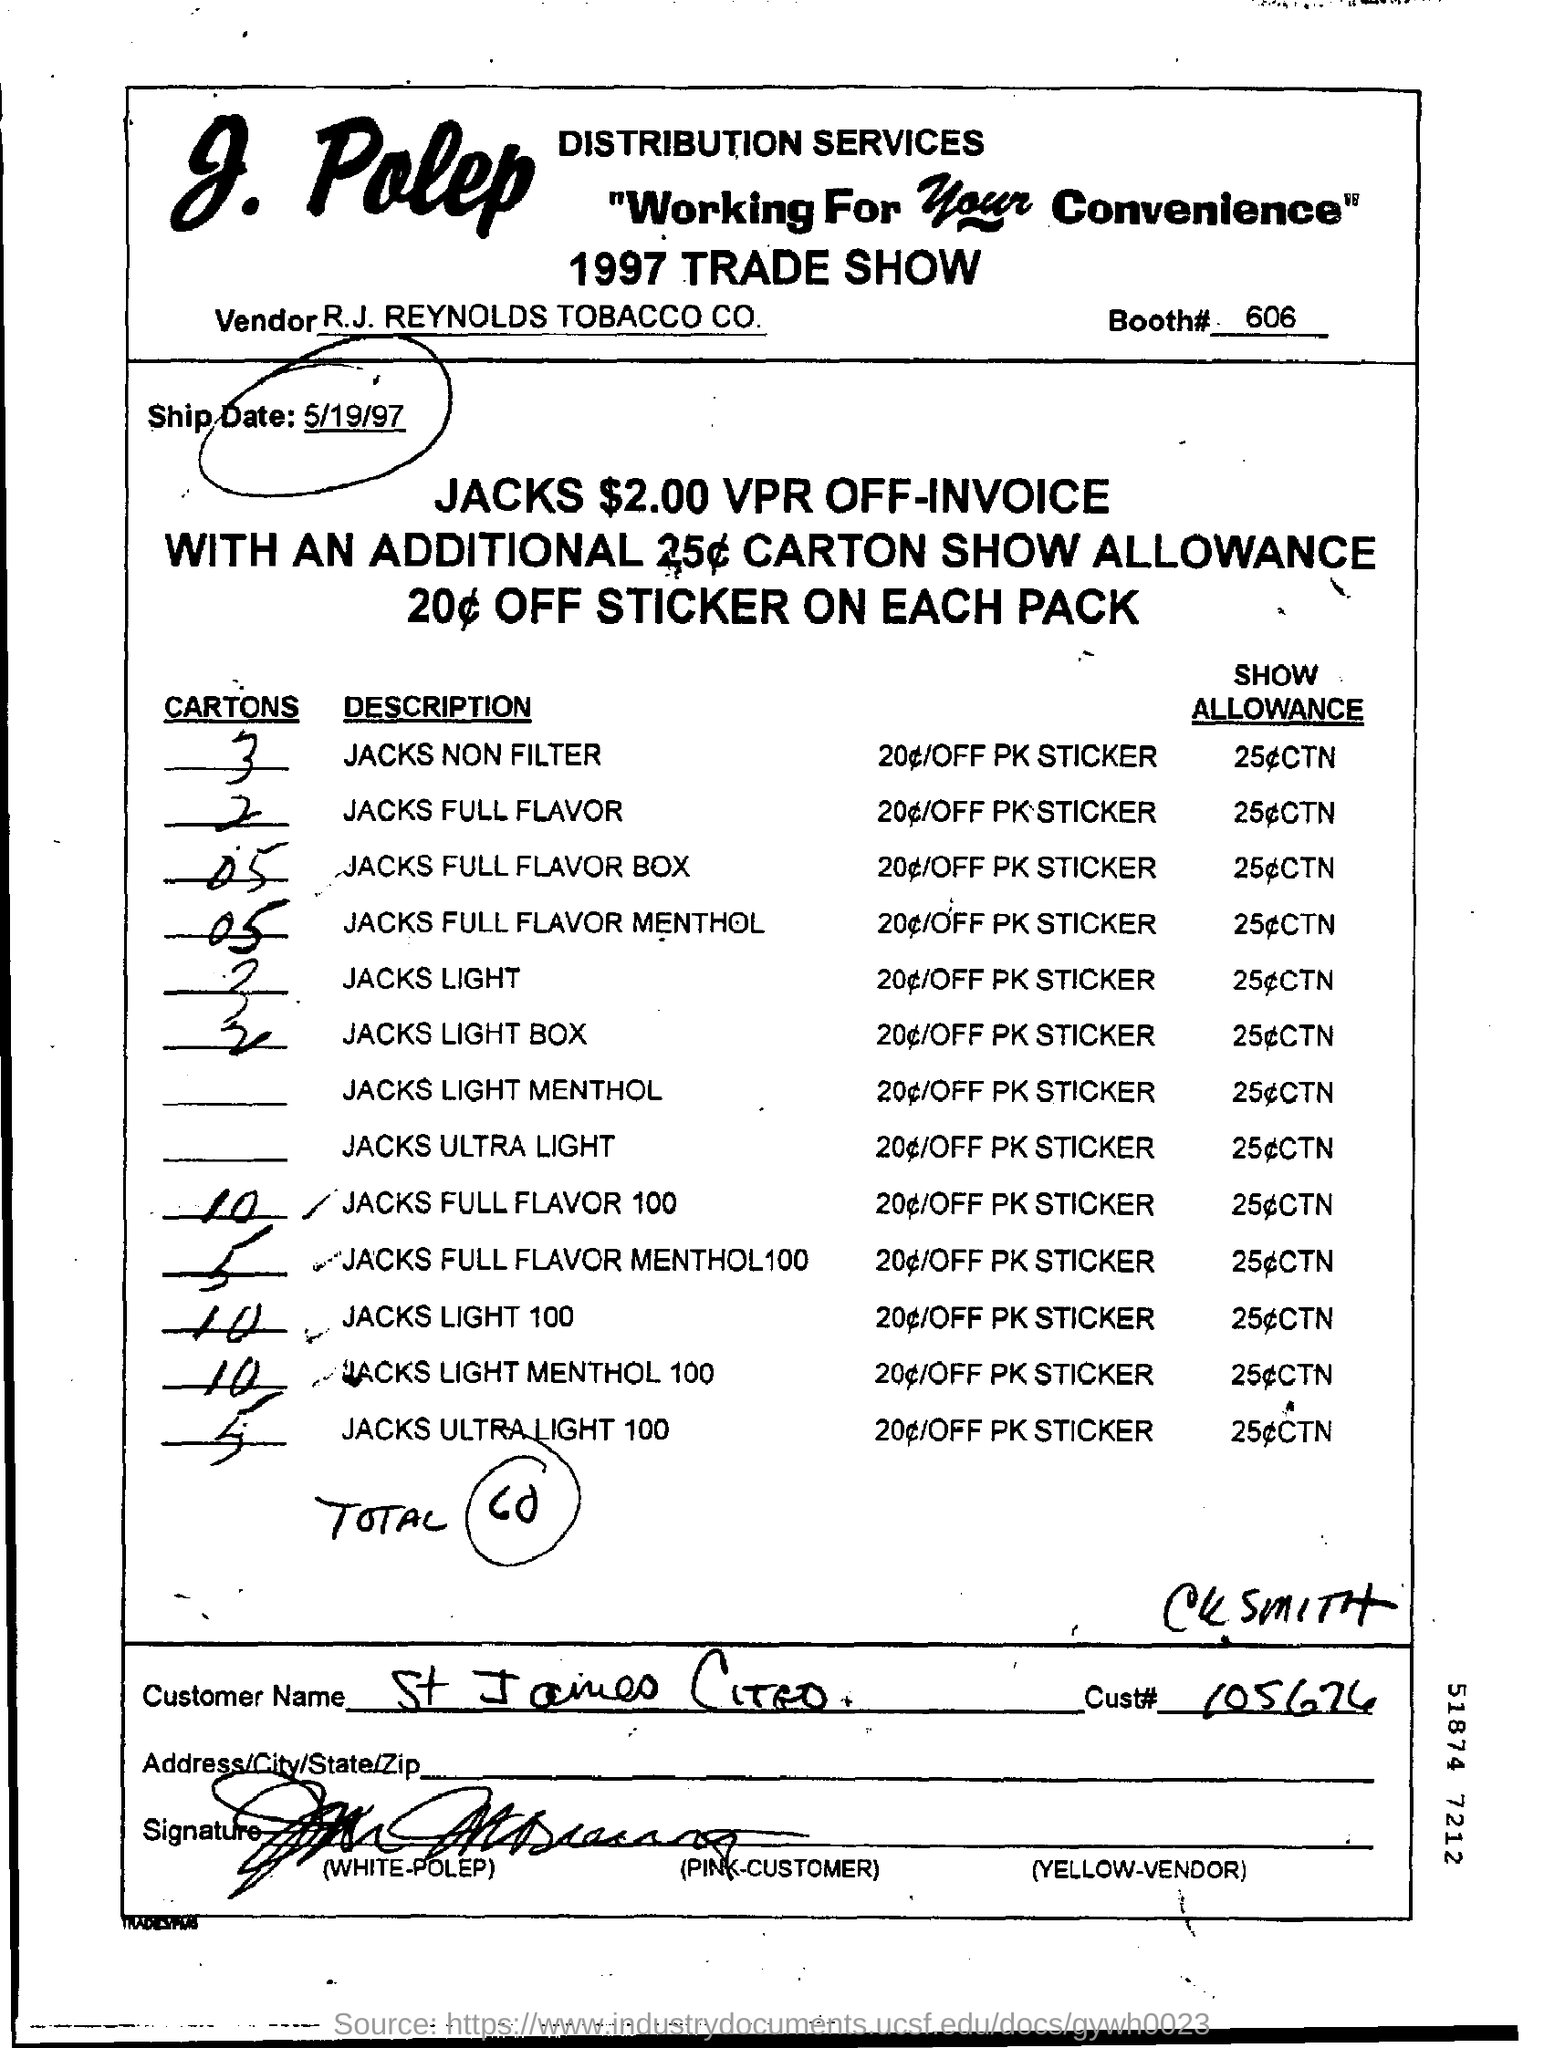What is the tagline given at the top?
Give a very brief answer. "working for your convenience". Who is the vendor?
Make the answer very short. R.J. Reynolds tobacco co. What is the ship date?
Make the answer very short. 5/19/97. What is the total number of cartons in the given document?
Offer a very short reply. 60. What is the customer name?
Offer a terse response. St james citeo. What is the customer id?
Make the answer very short. 105674. 